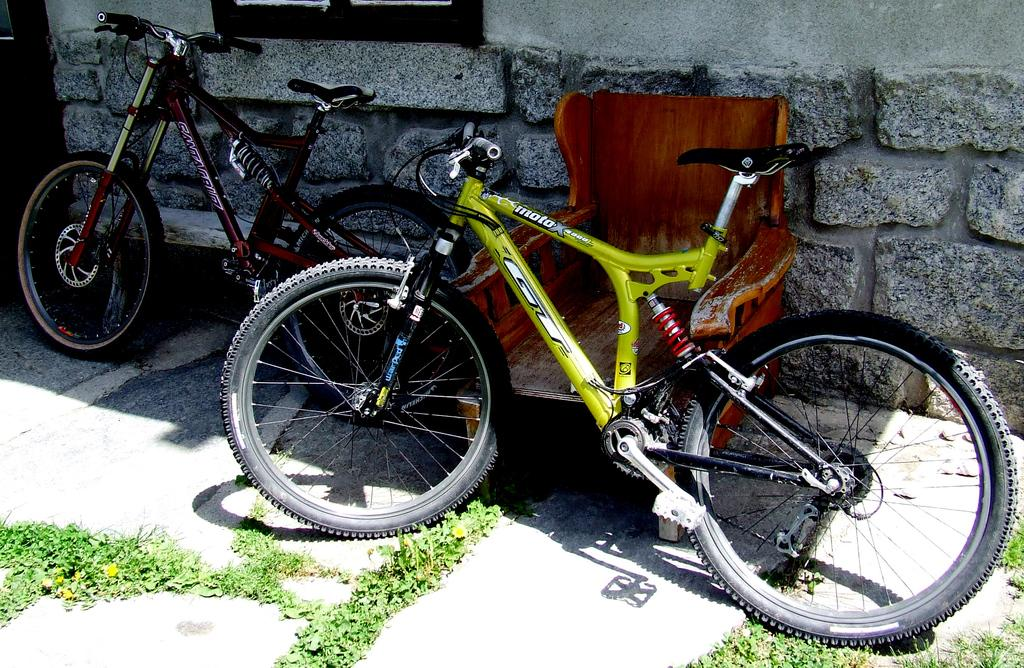How many cycles are present in the image? There are two cycles in the image. What type of furniture can be seen in the image? There is a chair in the image. What type of structure is visible in the image? There is a wall in the image. What architectural feature is present in the image? There is a door in the image. What type of surface is visible in the image? There is grass on the surface in the image. What color is the ball in the mouth of the person in the image? There is no person or ball present in the image; it features two cycles, a chair, a wall, a door, and grass on the surface. 